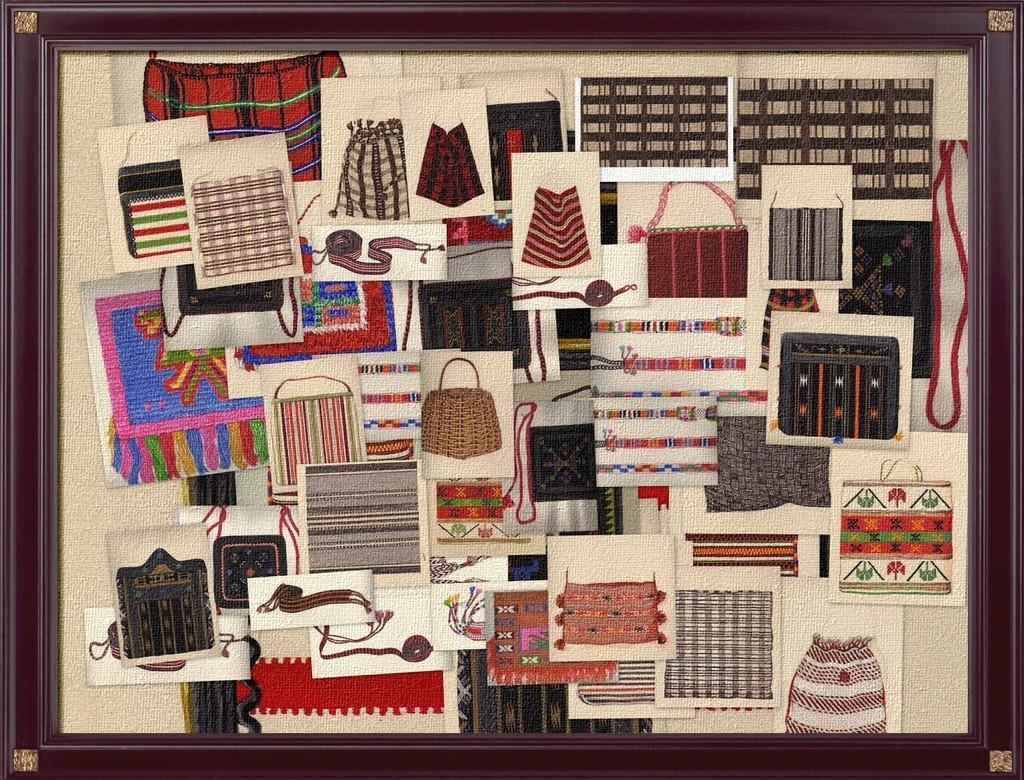How would you summarize this image in a sentence or two? In this picture we can see a frame, in the frame we can find few arts. 